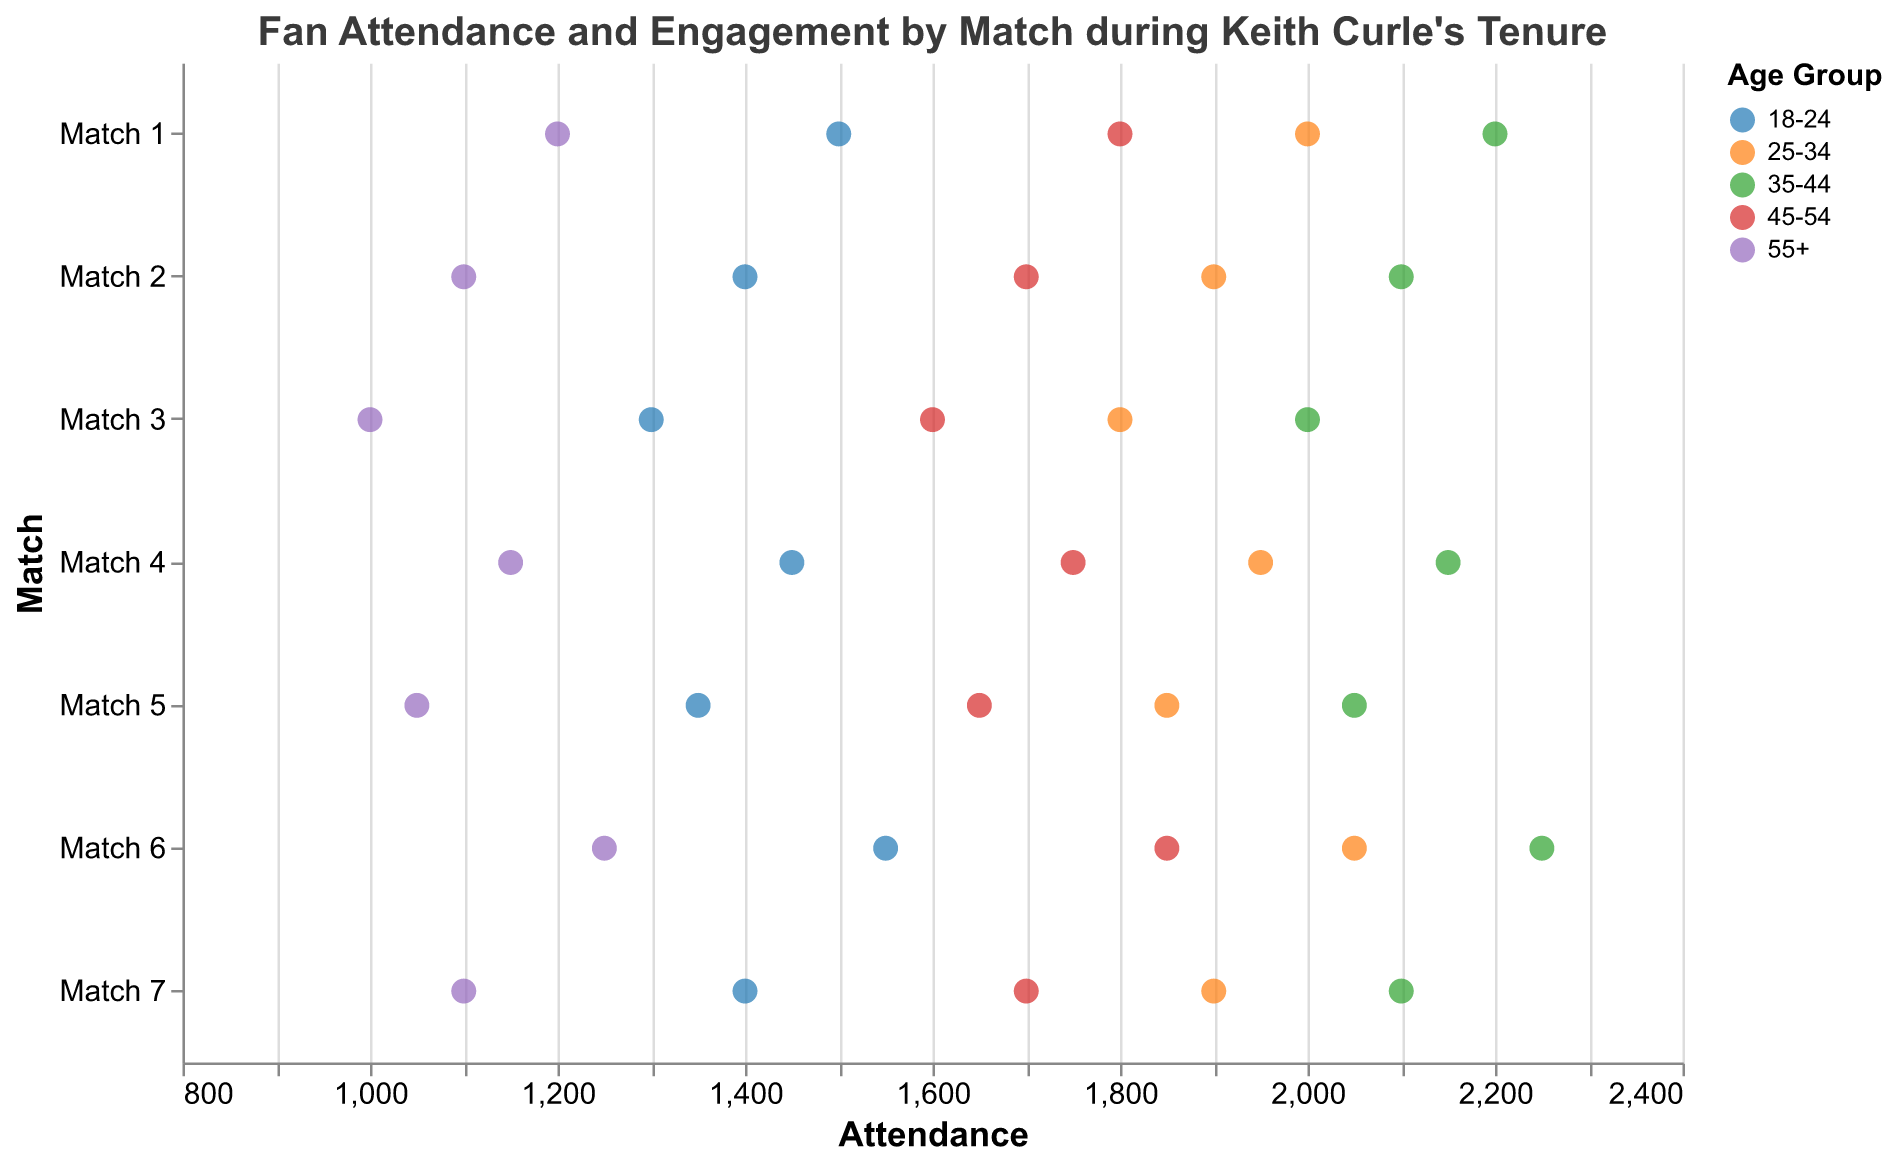How does the attendance of the 18-24 age group in Match 1 compare to that in Match 6? In Match 1, the 18-24 age group had an attendance of 1500. In Match 6, the attendance for the same age group rose to 1550. Therefore, there is an increase of 50 people in attendance for the 18-24 age group from Match 1 to Match 6.
Answer: The attendance increased by 50 Which age group in Leeds had the highest engagement in Match 3? In Match 3 in Leeds, the engagement values for age groups are as follows: 18-24: 80, 25-34: 88, 35-44: 84, 45-54: 78, and 55+: 70. The 25-34 age group has the highest engagement at 88.
Answer: 25-34 age group How did engagement in the 35-44 age group in Liverpool change from Match 2 to Match 5? In Match 2, the engagement for the 35-44 age group in Liverpool was 85. In Match 5, it increased to 86. Therefore, there was an increase of 1 in engagement.
Answer: Increased by 1 What is the average attendance for the 25-34 age group across all matches? The attendance for the 25-34 age group across all matches is as follows: 2000 (Match 1), 1900 (Match 2), 1800 (Match 3), 1950 (Match 4), 1850 (Match 5), 2050 (Match 6), 1900 (Match 7). Adding these gives 13450. Dividing by the number of matches (7), the average attendance is 13450/7 = 1921.4.
Answer: 1921.4 Which location had the lowest engagement in the 55+ age group? The engagement values for the 55+ age group are Manchester: 75 (Match 1), Liverpool: 72 (Matches 2 and 5), Leeds: 70 (Match 3), Birmingham: 74 (Match 4). The location with the lowest engagement is Leeds with an engagement value of 70.
Answer: Leeds What is the total attendance of the 18-24 age group in all matches combined? The attendance for the 18-24 age group is as follows: 1500 (Match 1), 1400 (Match 2), 1300 (Match 3), 1450 (Match 4), 1350 (Match 5), 1550 (Match 6), 1400 (Match 7). Adding these gives 9950.
Answer: 9950 What is the overall trend in engagement for the 25-34 age group across all matches? The engagement values for the 25-34 age group across matches are: Match 1: 90, Match 2: 89, Match 3: 88, Match 4: 91, Match 5: 87, Match 6: 92, Match 7: 89. The engagement values fluctuate but generally show stability, with some increase in the latter matches.
Answer: Generally stable with fluctuations 